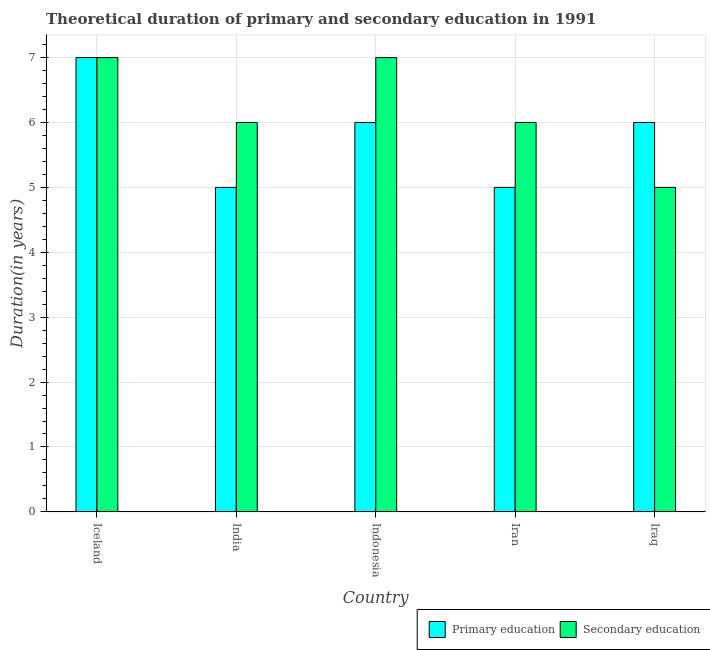How many different coloured bars are there?
Offer a very short reply. 2. Are the number of bars per tick equal to the number of legend labels?
Offer a terse response. Yes. How many bars are there on the 5th tick from the left?
Your answer should be very brief. 2. What is the duration of secondary education in Iran?
Offer a very short reply. 6. Across all countries, what is the maximum duration of primary education?
Give a very brief answer. 7. Across all countries, what is the minimum duration of primary education?
Make the answer very short. 5. In which country was the duration of secondary education maximum?
Provide a succinct answer. Iceland. What is the total duration of secondary education in the graph?
Your answer should be compact. 31. What is the difference between the duration of primary education in Iran and that in Iraq?
Make the answer very short. -1. What is the difference between the duration of secondary education in Iran and the duration of primary education in Iraq?
Keep it short and to the point. 0. What is the average duration of secondary education per country?
Your answer should be very brief. 6.2. What is the difference between the duration of primary education and duration of secondary education in India?
Your answer should be very brief. -1. What is the ratio of the duration of primary education in Iceland to that in Indonesia?
Give a very brief answer. 1.17. Is the duration of secondary education in Iceland less than that in Iraq?
Keep it short and to the point. No. Is the difference between the duration of secondary education in Iceland and India greater than the difference between the duration of primary education in Iceland and India?
Provide a short and direct response. No. What is the difference between the highest and the lowest duration of primary education?
Your answer should be compact. 2. Is the sum of the duration of primary education in India and Indonesia greater than the maximum duration of secondary education across all countries?
Offer a very short reply. Yes. What does the 2nd bar from the left in India represents?
Make the answer very short. Secondary education. What does the 2nd bar from the right in Iran represents?
Offer a terse response. Primary education. How many countries are there in the graph?
Offer a terse response. 5. What is the difference between two consecutive major ticks on the Y-axis?
Make the answer very short. 1. Where does the legend appear in the graph?
Offer a terse response. Bottom right. What is the title of the graph?
Ensure brevity in your answer.  Theoretical duration of primary and secondary education in 1991. What is the label or title of the X-axis?
Your answer should be compact. Country. What is the label or title of the Y-axis?
Your answer should be very brief. Duration(in years). What is the Duration(in years) in Primary education in India?
Offer a terse response. 5. What is the Duration(in years) in Secondary education in India?
Offer a terse response. 6. What is the Duration(in years) of Primary education in Indonesia?
Make the answer very short. 6. What is the Duration(in years) of Secondary education in Indonesia?
Offer a terse response. 7. What is the Duration(in years) in Primary education in Iran?
Your answer should be very brief. 5. What is the Duration(in years) of Secondary education in Iran?
Provide a succinct answer. 6. What is the Duration(in years) of Primary education in Iraq?
Your response must be concise. 6. What is the difference between the Duration(in years) in Secondary education in Iceland and that in Indonesia?
Provide a succinct answer. 0. What is the difference between the Duration(in years) in Primary education in Iceland and that in Iran?
Offer a terse response. 2. What is the difference between the Duration(in years) of Primary education in Iceland and that in Iraq?
Offer a very short reply. 1. What is the difference between the Duration(in years) of Primary education in India and that in Indonesia?
Offer a very short reply. -1. What is the difference between the Duration(in years) in Primary education in India and that in Iran?
Give a very brief answer. 0. What is the difference between the Duration(in years) in Primary education in India and that in Iraq?
Your answer should be compact. -1. What is the difference between the Duration(in years) in Primary education in Indonesia and that in Iran?
Give a very brief answer. 1. What is the difference between the Duration(in years) of Primary education in Iceland and the Duration(in years) of Secondary education in India?
Your answer should be compact. 1. What is the difference between the Duration(in years) of Primary education in Iceland and the Duration(in years) of Secondary education in Iraq?
Offer a terse response. 2. What is the difference between the Duration(in years) in Primary education in Indonesia and the Duration(in years) in Secondary education in Iran?
Provide a short and direct response. 0. What is the difference between the Duration(in years) of Primary education and Duration(in years) of Secondary education in Iceland?
Give a very brief answer. 0. What is the difference between the Duration(in years) in Primary education and Duration(in years) in Secondary education in India?
Ensure brevity in your answer.  -1. What is the difference between the Duration(in years) in Primary education and Duration(in years) in Secondary education in Iran?
Your response must be concise. -1. What is the ratio of the Duration(in years) of Primary education in Iceland to that in Indonesia?
Your answer should be compact. 1.17. What is the ratio of the Duration(in years) of Secondary education in Iceland to that in Indonesia?
Give a very brief answer. 1. What is the ratio of the Duration(in years) in Primary education in Iceland to that in Iran?
Offer a very short reply. 1.4. What is the ratio of the Duration(in years) of Primary education in Iceland to that in Iraq?
Keep it short and to the point. 1.17. What is the ratio of the Duration(in years) in Secondary education in Iceland to that in Iraq?
Provide a succinct answer. 1.4. What is the ratio of the Duration(in years) of Primary education in India to that in Indonesia?
Make the answer very short. 0.83. What is the ratio of the Duration(in years) of Primary education in India to that in Iran?
Provide a succinct answer. 1. What is the ratio of the Duration(in years) of Secondary education in India to that in Iraq?
Your response must be concise. 1.2. What is the ratio of the Duration(in years) in Primary education in Indonesia to that in Iran?
Provide a succinct answer. 1.2. What is the ratio of the Duration(in years) of Primary education in Indonesia to that in Iraq?
Make the answer very short. 1. 